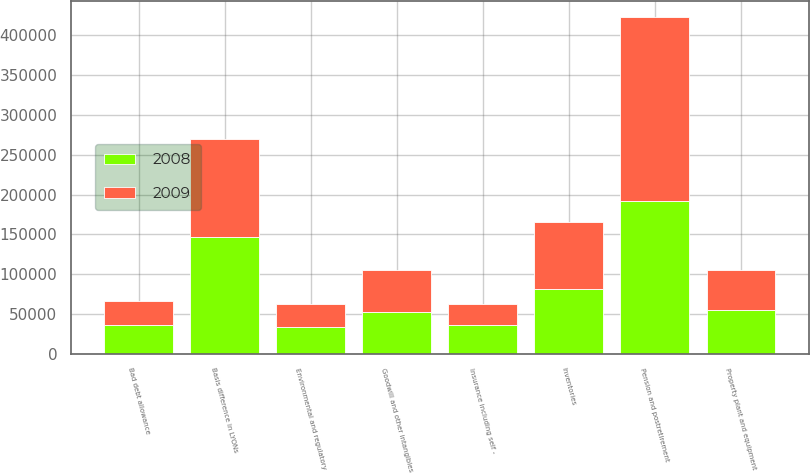<chart> <loc_0><loc_0><loc_500><loc_500><stacked_bar_chart><ecel><fcel>Bad debt allowance<fcel>Inventories<fcel>Property plant and equipment<fcel>Pension and postretirement<fcel>Insurance including self -<fcel>Basis difference in LYONs<fcel>Goodwill and other intangibles<fcel>Environmental and regulatory<nl><fcel>2008<fcel>35560<fcel>81396<fcel>54836<fcel>192298<fcel>35548<fcel>146598<fcel>52839.5<fcel>33251<nl><fcel>2009<fcel>31179<fcel>84154<fcel>50843<fcel>230134<fcel>26596<fcel>122999<fcel>52839.5<fcel>29712<nl></chart> 